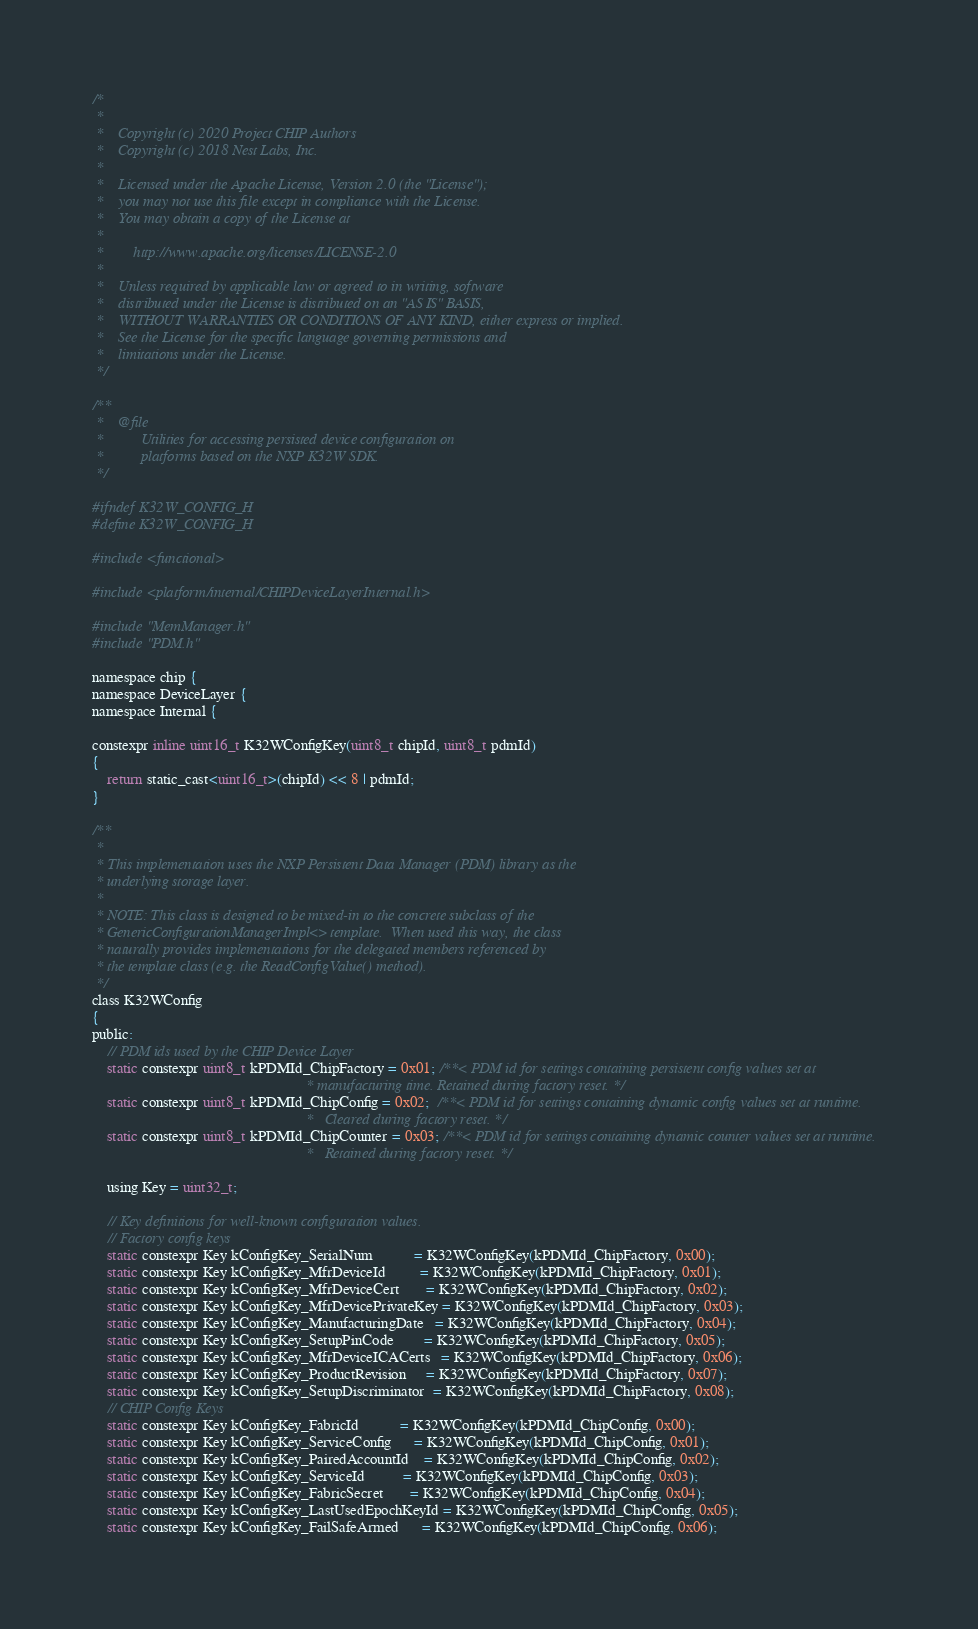<code> <loc_0><loc_0><loc_500><loc_500><_C_>/*
 *
 *    Copyright (c) 2020 Project CHIP Authors
 *    Copyright (c) 2018 Nest Labs, Inc.
 *
 *    Licensed under the Apache License, Version 2.0 (the "License");
 *    you may not use this file except in compliance with the License.
 *    You may obtain a copy of the License at
 *
 *        http://www.apache.org/licenses/LICENSE-2.0
 *
 *    Unless required by applicable law or agreed to in writing, software
 *    distributed under the License is distributed on an "AS IS" BASIS,
 *    WITHOUT WARRANTIES OR CONDITIONS OF ANY KIND, either express or implied.
 *    See the License for the specific language governing permissions and
 *    limitations under the License.
 */

/**
 *    @file
 *          Utilities for accessing persisted device configuration on
 *          platforms based on the NXP K32W SDK.
 */

#ifndef K32W_CONFIG_H
#define K32W_CONFIG_H

#include <functional>

#include <platform/internal/CHIPDeviceLayerInternal.h>

#include "MemManager.h"
#include "PDM.h"

namespace chip {
namespace DeviceLayer {
namespace Internal {

constexpr inline uint16_t K32WConfigKey(uint8_t chipId, uint8_t pdmId)
{
    return static_cast<uint16_t>(chipId) << 8 | pdmId;
}

/**
 *
 * This implementation uses the NXP Persistent Data Manager (PDM) library as the
 * underlying storage layer.
 *
 * NOTE: This class is designed to be mixed-in to the concrete subclass of the
 * GenericConfigurationManagerImpl<> template.  When used this way, the class
 * naturally provides implementations for the delegated members referenced by
 * the template class (e.g. the ReadConfigValue() method).
 */
class K32WConfig
{
public:
    // PDM ids used by the CHIP Device Layer
    static constexpr uint8_t kPDMId_ChipFactory = 0x01; /**< PDM id for settings containing persistent config values set at
                                                         * manufacturing time. Retained during factory reset. */
    static constexpr uint8_t kPDMId_ChipConfig = 0x02;  /**< PDM id for settings containing dynamic config values set at runtime.
                                                         *   Cleared during factory reset. */
    static constexpr uint8_t kPDMId_ChipCounter = 0x03; /**< PDM id for settings containing dynamic counter values set at runtime.
                                                         *   Retained during factory reset. */

    using Key = uint32_t;

    // Key definitions for well-known configuration values.
    // Factory config keys
    static constexpr Key kConfigKey_SerialNum           = K32WConfigKey(kPDMId_ChipFactory, 0x00);
    static constexpr Key kConfigKey_MfrDeviceId         = K32WConfigKey(kPDMId_ChipFactory, 0x01);
    static constexpr Key kConfigKey_MfrDeviceCert       = K32WConfigKey(kPDMId_ChipFactory, 0x02);
    static constexpr Key kConfigKey_MfrDevicePrivateKey = K32WConfigKey(kPDMId_ChipFactory, 0x03);
    static constexpr Key kConfigKey_ManufacturingDate   = K32WConfigKey(kPDMId_ChipFactory, 0x04);
    static constexpr Key kConfigKey_SetupPinCode        = K32WConfigKey(kPDMId_ChipFactory, 0x05);
    static constexpr Key kConfigKey_MfrDeviceICACerts   = K32WConfigKey(kPDMId_ChipFactory, 0x06);
    static constexpr Key kConfigKey_ProductRevision     = K32WConfigKey(kPDMId_ChipFactory, 0x07);
    static constexpr Key kConfigKey_SetupDiscriminator  = K32WConfigKey(kPDMId_ChipFactory, 0x08);
    // CHIP Config Keys
    static constexpr Key kConfigKey_FabricId           = K32WConfigKey(kPDMId_ChipConfig, 0x00);
    static constexpr Key kConfigKey_ServiceConfig      = K32WConfigKey(kPDMId_ChipConfig, 0x01);
    static constexpr Key kConfigKey_PairedAccountId    = K32WConfigKey(kPDMId_ChipConfig, 0x02);
    static constexpr Key kConfigKey_ServiceId          = K32WConfigKey(kPDMId_ChipConfig, 0x03);
    static constexpr Key kConfigKey_FabricSecret       = K32WConfigKey(kPDMId_ChipConfig, 0x04);
    static constexpr Key kConfigKey_LastUsedEpochKeyId = K32WConfigKey(kPDMId_ChipConfig, 0x05);
    static constexpr Key kConfigKey_FailSafeArmed      = K32WConfigKey(kPDMId_ChipConfig, 0x06);
</code> 